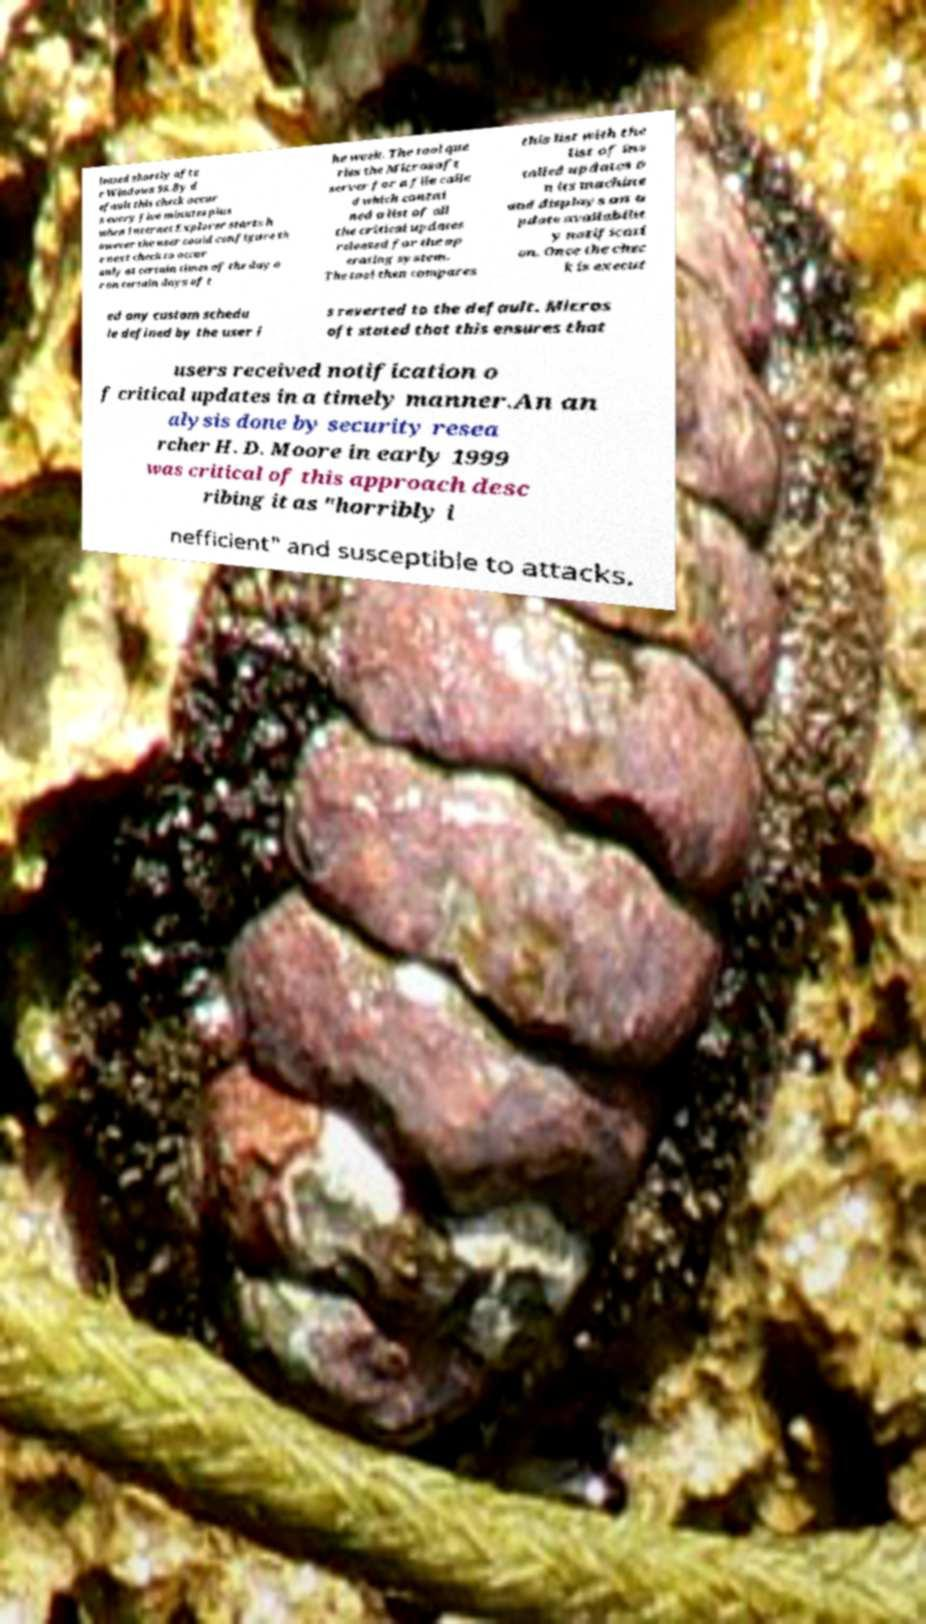I need the written content from this picture converted into text. Can you do that? leased shortly afte r Windows 98.By d efault this check occur s every five minutes plus when Internet Explorer starts h owever the user could configure th e next check to occur only at certain times of the day o r on certain days of t he week. The tool que ries the Microsoft server for a file calle d which contai ned a list of all the critical updates released for the op erating system. The tool then compares this list with the list of ins talled updates o n its machine and displays an u pdate availabilit y notificati on. Once the chec k is execut ed any custom schedu le defined by the user i s reverted to the default. Micros oft stated that this ensures that users received notification o f critical updates in a timely manner.An an alysis done by security resea rcher H. D. Moore in early 1999 was critical of this approach desc ribing it as "horribly i nefficient" and susceptible to attacks. 